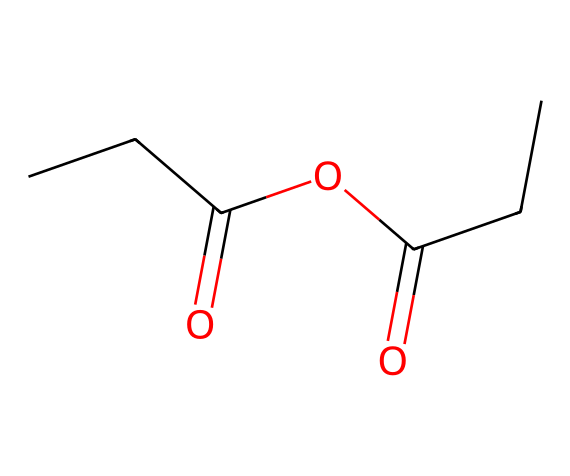how many carbon atoms are in propionic anhydride? The SMILES representation CCC(=O)OC(=O)CC indicates there are five carbon atoms (C) in total, coming from the two propionic acid moieties.
Answer: five what type of functional groups are present in propionic anhydride? The chemical structure contains an anhydride functional group, which is indicated by the carbonyl (C=O) groups adjacent to the ether (C-O-C) linkage.
Answer: anhydride, ether what is the main use of propionic anhydride in perfumes? Propionic anhydride is commonly used as a building block for creating various fragrance compounds due to its reactivity and ability to form esters.
Answer: fragrance compounds how many oxygen atoms are in propionic anhydride? The structure shows a total of three oxygen atoms: two from the carbonyl groups and one from the ether linkage.
Answer: three does propionic anhydride exhibit any characteristic odors? Yes, propionic anhydride typically has a slightly pungent, sweet smell, which can contribute to the overall aroma profile in perfumes.
Answer: pungent, sweet what is the significance of the anhydride in propionic anhydride? As an anhydride, it plays a crucial role in reacting with alcohols to produce esters, key components in many fragrance formulations.
Answer: reacts with alcohols to form esters 